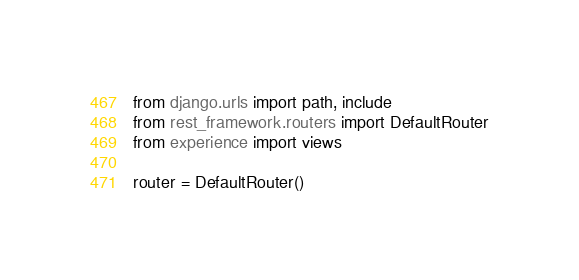Convert code to text. <code><loc_0><loc_0><loc_500><loc_500><_Python_>from django.urls import path, include
from rest_framework.routers import DefaultRouter
from experience import views

router = DefaultRouter()</code> 